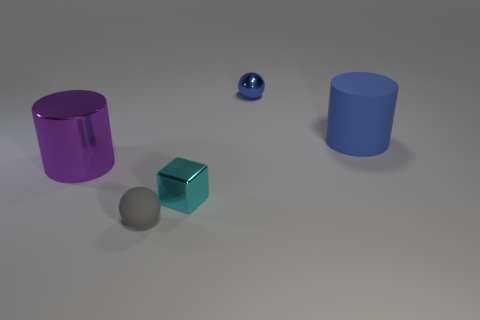Add 2 small purple matte balls. How many objects exist? 7 Subtract all blocks. How many objects are left? 4 Add 4 tiny green matte things. How many tiny green matte things exist? 4 Subtract all blue cylinders. How many cylinders are left? 1 Subtract 0 red spheres. How many objects are left? 5 Subtract all cyan cylinders. Subtract all gray balls. How many cylinders are left? 2 Subtract all gray blocks. How many purple cylinders are left? 1 Subtract all big green spheres. Subtract all large matte cylinders. How many objects are left? 4 Add 5 big rubber cylinders. How many big rubber cylinders are left? 6 